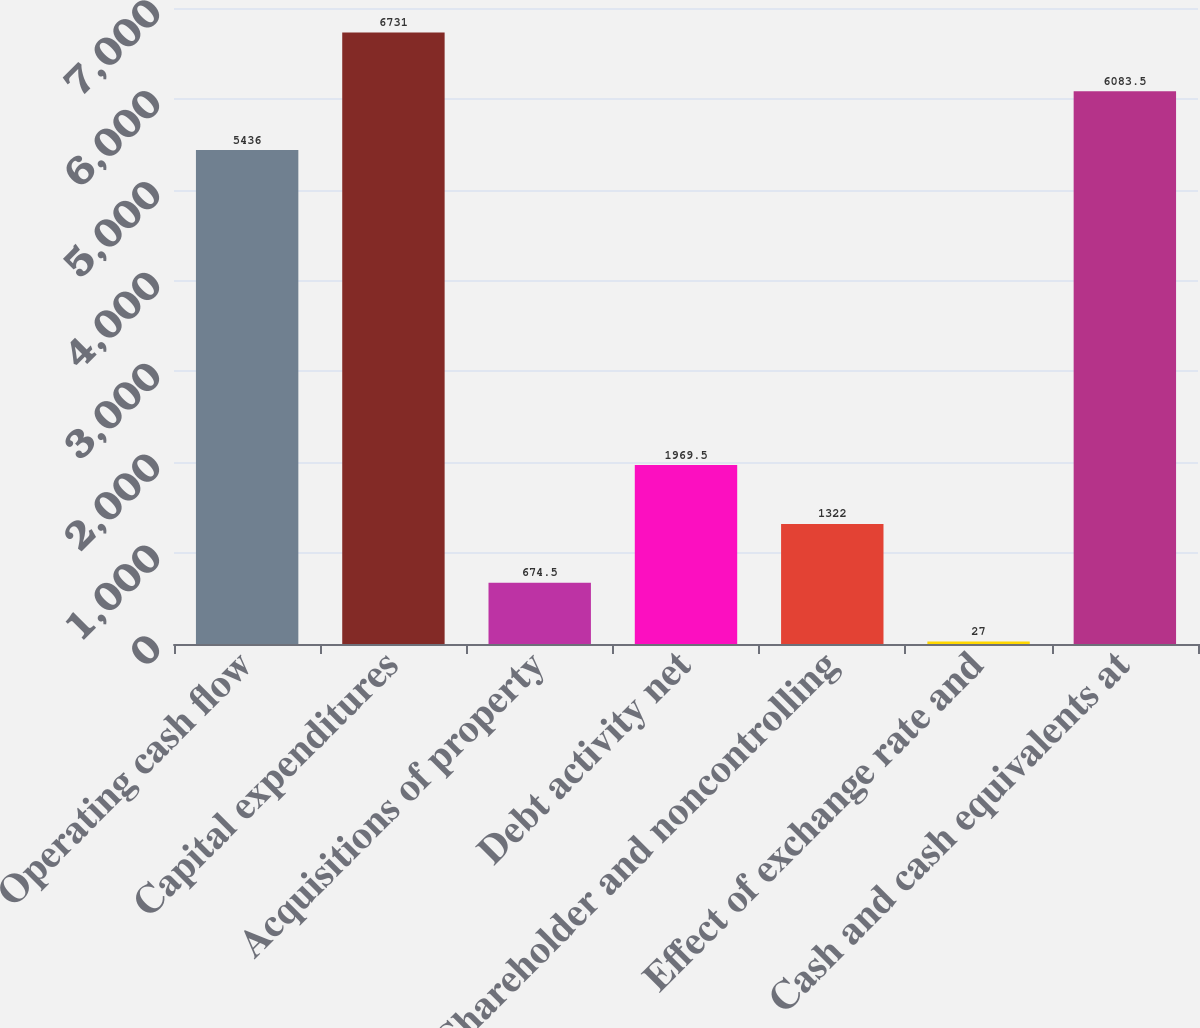Convert chart to OTSL. <chart><loc_0><loc_0><loc_500><loc_500><bar_chart><fcel>Operating cash flow<fcel>Capital expenditures<fcel>Acquisitions of property<fcel>Debt activity net<fcel>Shareholder and noncontrolling<fcel>Effect of exchange rate and<fcel>Cash and cash equivalents at<nl><fcel>5436<fcel>6731<fcel>674.5<fcel>1969.5<fcel>1322<fcel>27<fcel>6083.5<nl></chart> 